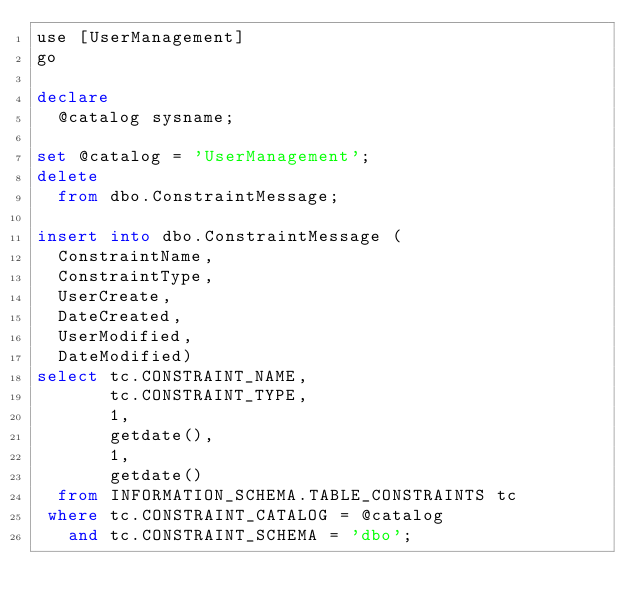<code> <loc_0><loc_0><loc_500><loc_500><_SQL_>use [UserManagement]
go

declare
  @catalog sysname;
  
set @catalog = 'UserManagement';
delete
  from dbo.ConstraintMessage; 

insert into dbo.ConstraintMessage (
  ConstraintName,
  ConstraintType,
  UserCreate,
  DateCreated,
  UserModified,
  DateModified)
select tc.CONSTRAINT_NAME,
       tc.CONSTRAINT_TYPE,
       1,
       getdate(),
       1,
       getdate()
  from INFORMATION_SCHEMA.TABLE_CONSTRAINTS tc
 where tc.CONSTRAINT_CATALOG = @catalog  
   and tc.CONSTRAINT_SCHEMA = 'dbo';
</code> 